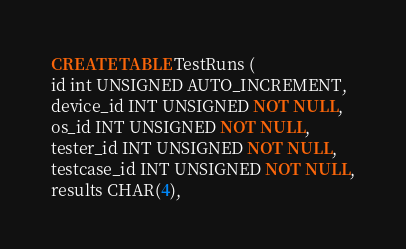<code> <loc_0><loc_0><loc_500><loc_500><_SQL_>CREATE TABLE TestRuns (
id int UNSIGNED AUTO_INCREMENT,
device_id INT UNSIGNED NOT NULL,
os_id INT UNSIGNED NOT NULL,
tester_id INT UNSIGNED NOT NULL,
testcase_id INT UNSIGNED NOT NULL,
results CHAR(4),</code> 